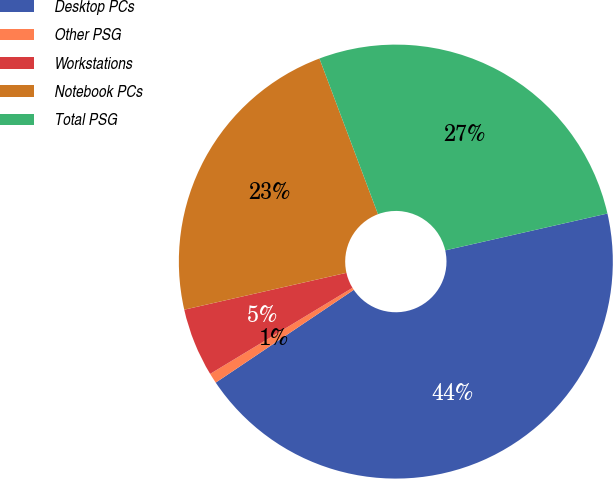<chart> <loc_0><loc_0><loc_500><loc_500><pie_chart><fcel>Desktop PCs<fcel>Other PSG<fcel>Workstations<fcel>Notebook PCs<fcel>Total PSG<nl><fcel>44.14%<fcel>0.76%<fcel>5.1%<fcel>22.83%<fcel>27.17%<nl></chart> 